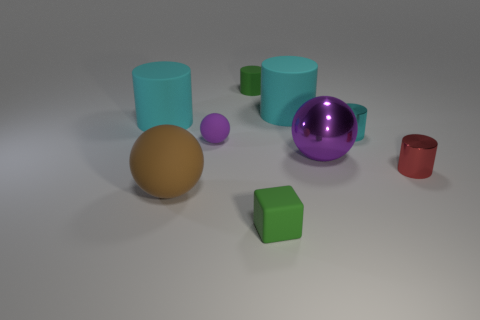How many other tiny things have the same material as the small cyan thing? In the image, there appears to be only one other small object that shares the same glossy material characteristic as the small cyan cylinder. It's the purple sphere. 